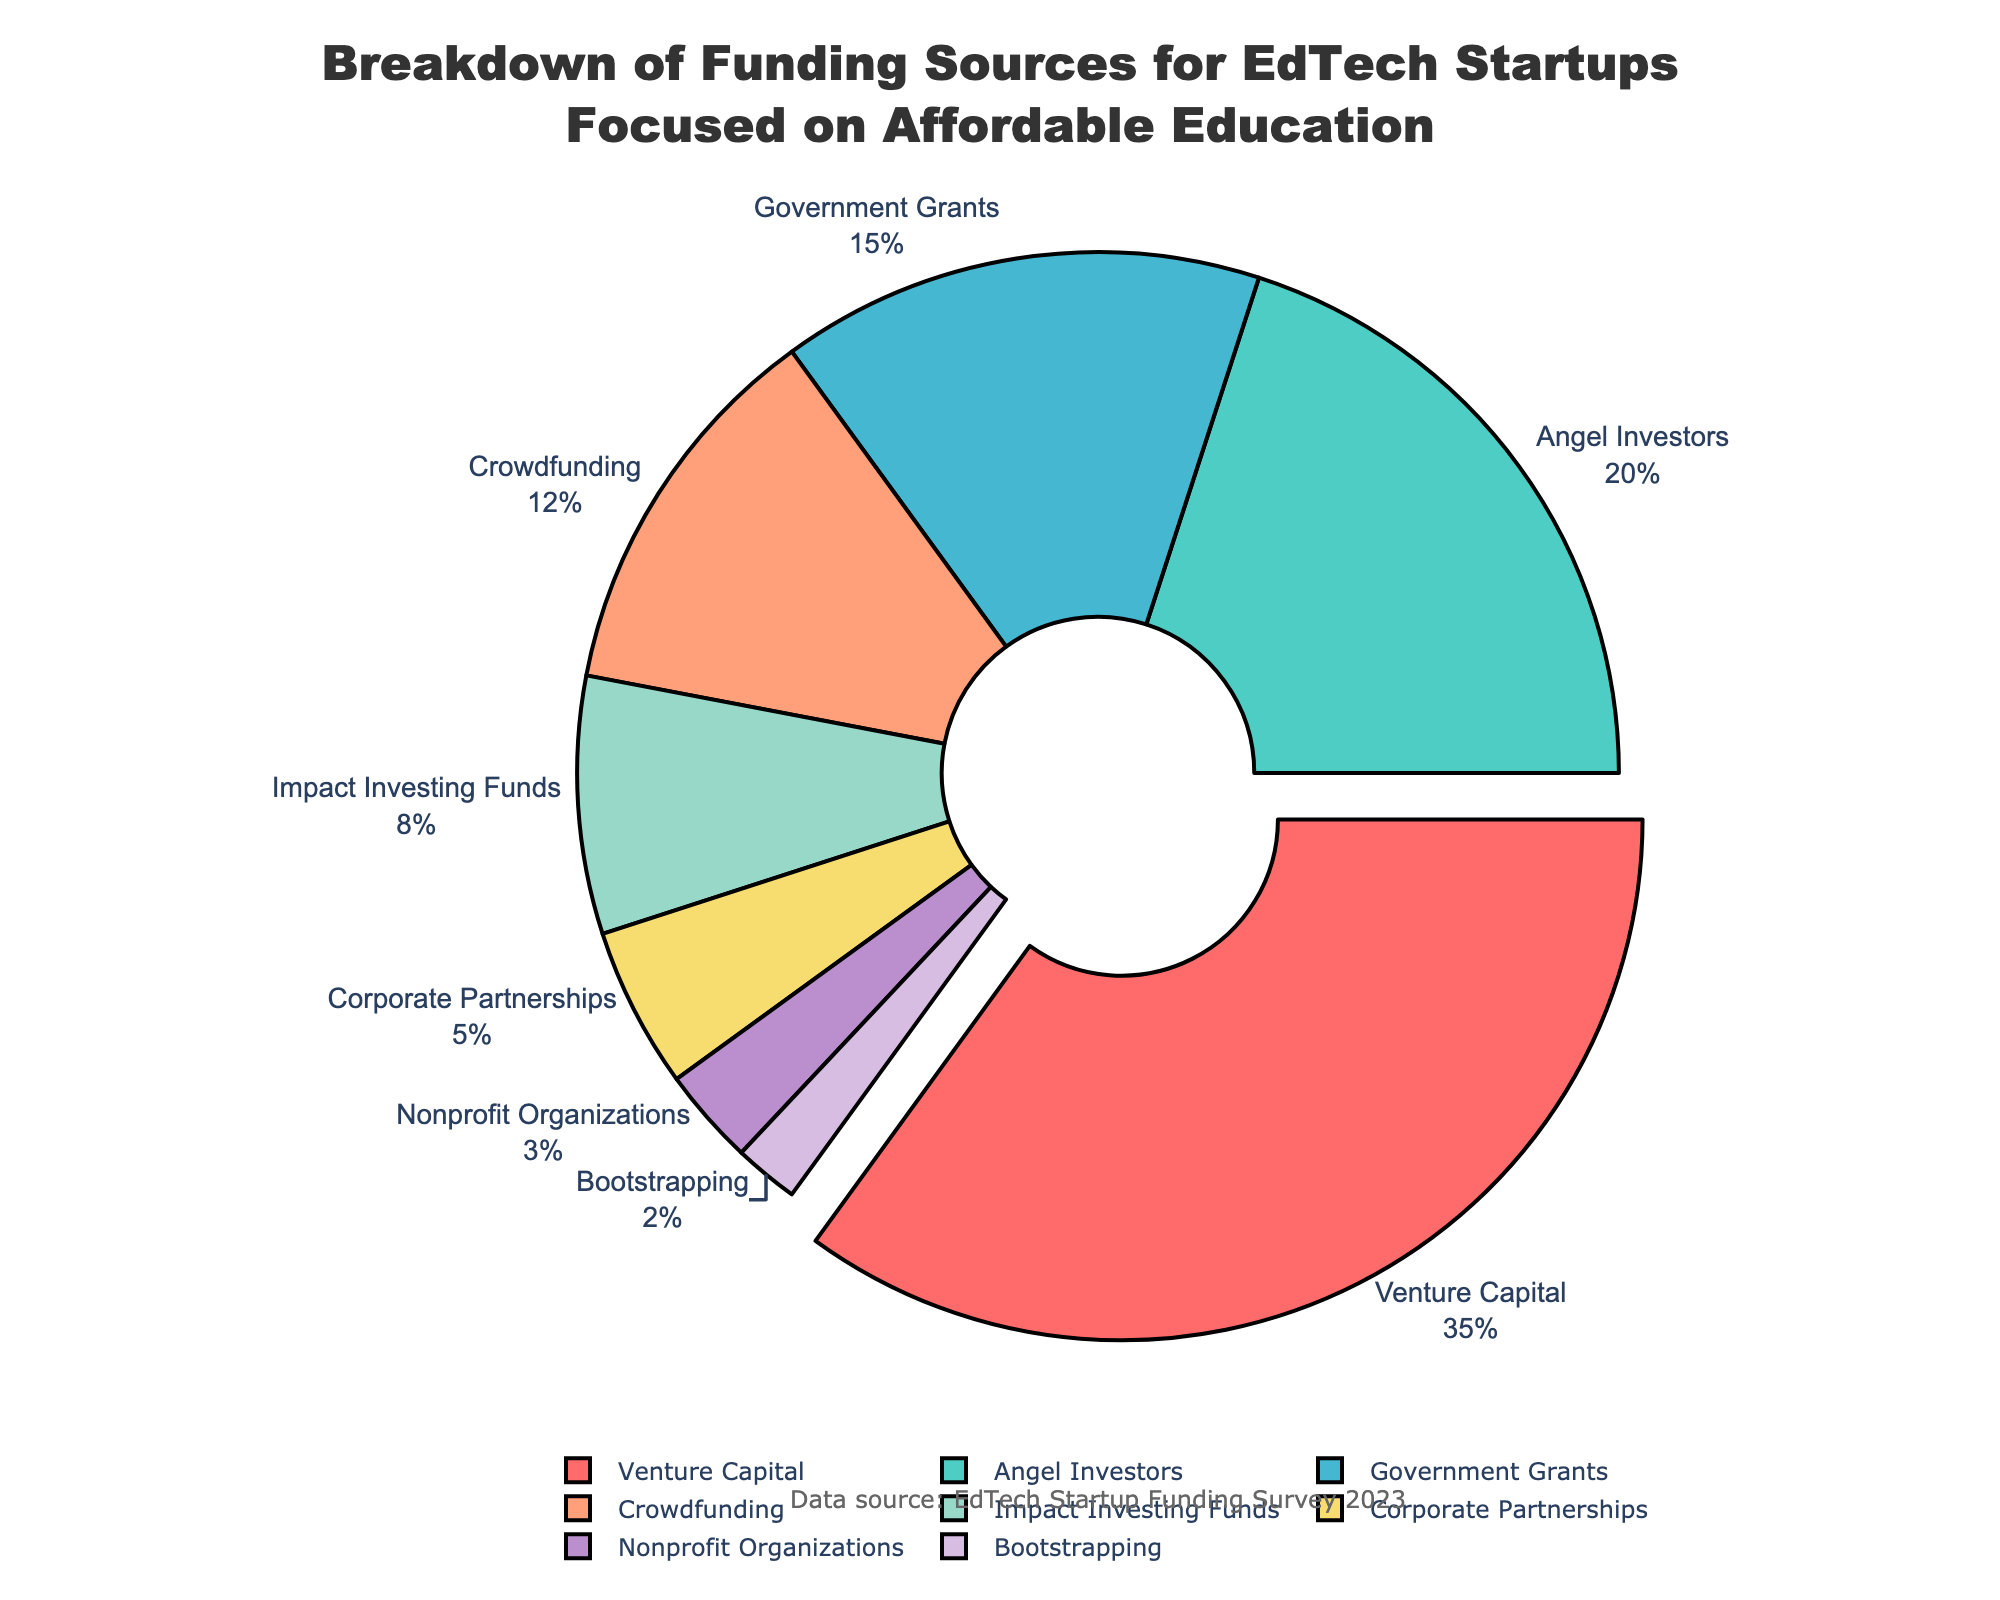What percentage of funding comes from Venture Capital and Angel Investors combined? Add the percentages of Venture Capital (35%) and Angel Investors (20%): 35 + 20 = 55
Answer: 55% Which funding source contributes the least? Identify the source with the smallest percentage; Bootstrapping has 2%, the lowest of all listed sources
Answer: Bootstrapping Is the percentage of Government Grants more or less than half of the percentage of Venture Capital? Compare Government Grants (15%) with half of Venture Capital (35%/2 = 17.5%); 15 is less than 17.5
Answer: Less What funding sources have a lower percentage than Crowdfunding? Identify all sources with percentages below Crowdfunding (12%): Impact Investing Funds (8%), Corporate Partnerships (5%), Nonprofit Organizations (3%), and Bootstrapping (2%) are lower
Answer: Impact Investing Funds, Corporate Partnerships, Nonprofit Organizations, Bootstrapping By how much does the percentage of Crowdfunding exceed the percentage of Nonprofit Organizations? Subtract the percentage of Nonprofit Organizations (3%) from Crowdfunding (12%): 12 - 3 = 9
Answer: 9 Which funding source’s percentage is represented by the color green in the pie chart? Identify the label associated with the green section of the pie chart; Angel Investors are represented by green
Answer: Angel Investors What is the median value of the percentages? Arrange the percentages in ascending order: 2, 3, 5, 8, 12, 15, 20, 35. The middle values are 8 and 12, so the median is (8+12)/2 = 10
Answer: 10 Which funding source has exactly double the percentage of Bootstrapping? Identify the source with a percentage of 2 * Bootstrapping (2%): Impact Investing Funds have 8%, so the answer is 2% * 4 = 8%
Answer: Impact Investing Funds Is the total percentage of Corporate Partnerships and Nonprofit Organizations less than the percentage of Government Grants? Add Corporate Partnerships (5%) and Nonprofit Organizations (3%) for a total of 8%; compare this with Government Grants (15%); 8 is less than 15
Answer: Yes What are the two largest funding sources in terms of percentage? Identify the two sources with the highest percentages: Venture Capital (35%) and Angel Investors (20%)
Answer: Venture Capital, Angel Investors 